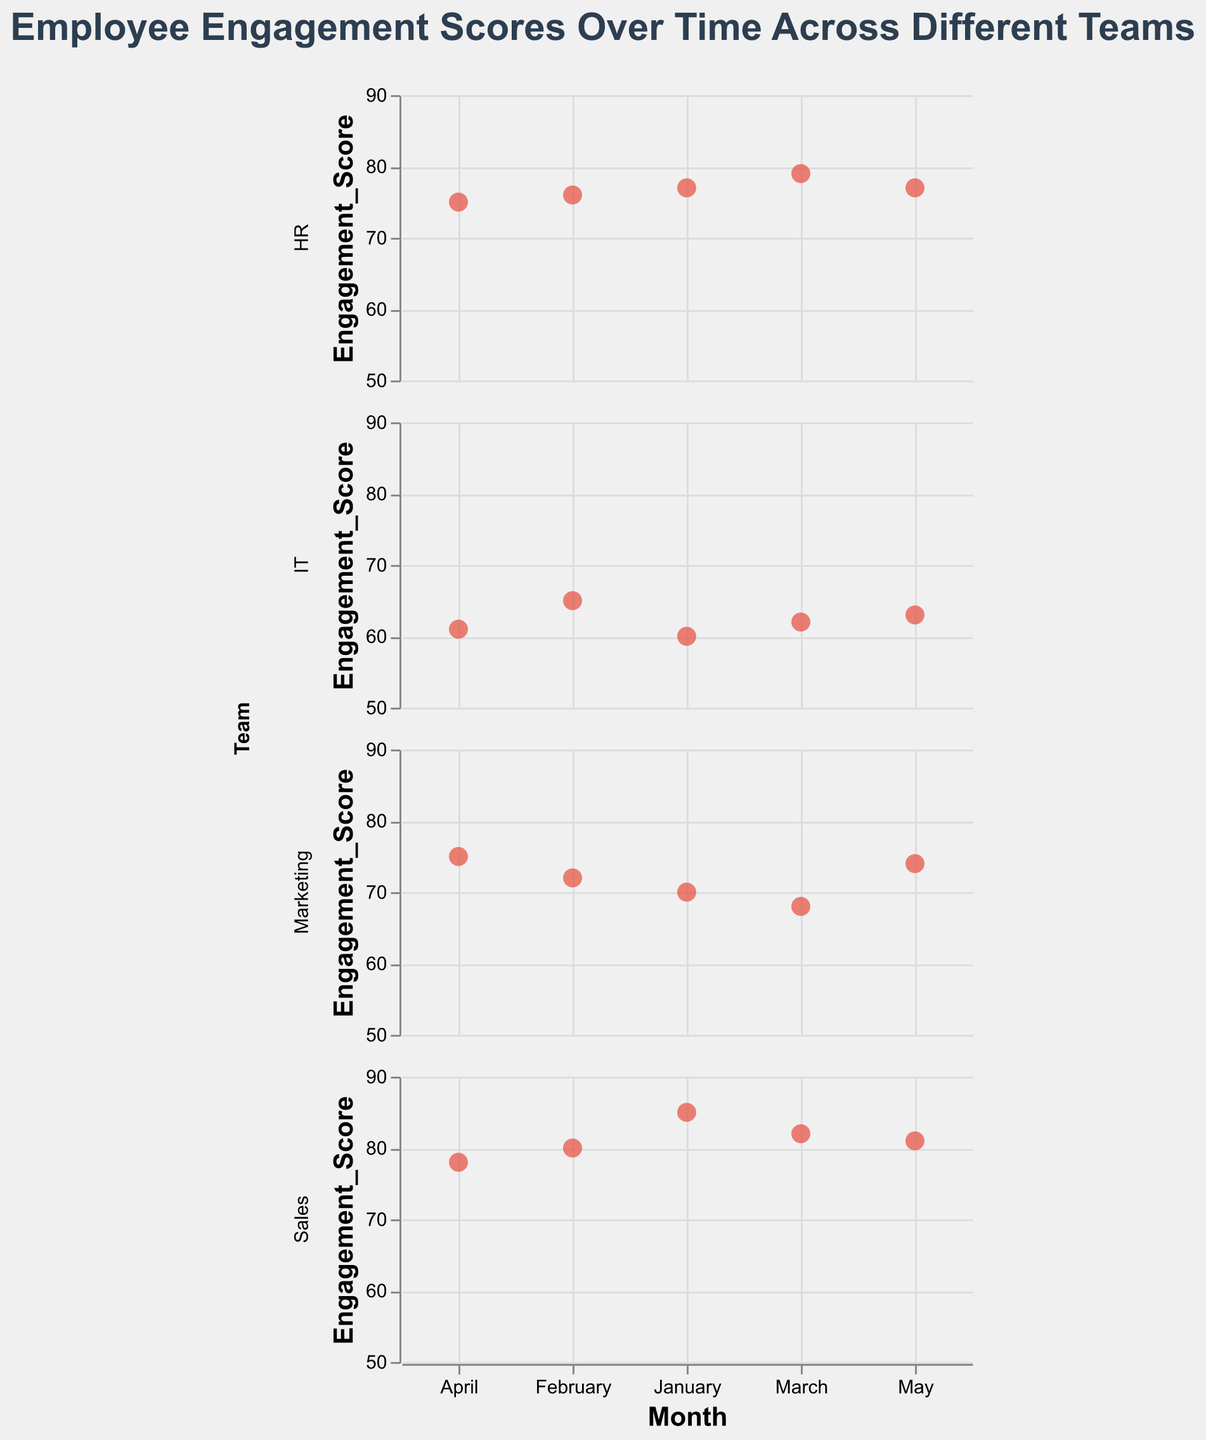What is the title of the figure? The title is usually displayed at the top of the figure and provides a summary of what the figure represents. In this case, it should be "Employee Engagement Scores Over Time Across Different Teams."
Answer: Employee Engagement Scores Over Time Across Different Teams How many teams are displayed in the figure? By looking at the labels or sections on the vertical axis (faceted rows), you can count the number of different teams. Here, the teams are Marketing, Sales, IT, and HR.
Answer: 4 Which team has the highest engagement score in January? By checking the January data points for all teams, we see that the Sales team has the highest engagement score of 85.
Answer: Sales Which team shows the largest increase in engagement score from January to February? We need to calculate the increase for each team: 
- Marketing: 72 - 70 = 2
- Sales: 80 - 85 = -5
- IT: 65 - 60 = 5
- HR: 76 - 77 = -1
The IT team shows the largest increase of 5 points.
Answer: IT Which team had the lowest engagement score in May? By examining the data points for May, we can see:
- Marketing: 74
- Sales: 81
- IT: 63
- HR: 77
The IT team has the lowest engagement score in May with 63 points.
Answer: IT What is the average engagement score for the HR team over the months shown? To calculate the average, sum the scores and divide by the number of months. 
- HR Scores: 77 + 76 + 79 + 75 + 77 = 384
- Number of Months: 5
Average = 384 / 5 = 76.8
Answer: 76.8 Which month shows the most significant drop in engagement score for any team? Check each team for the largest drop between successive months:
- Marketing: March (68) to April (75) (-7)
- Sales: February (80) to March (82) (-2)
- IT: February (65) to March (62) (-3)
- HR: April (75) to May (77) (-2)
The largest drop is for Marketing from February to March with a decrease of 7 points.
Answer: March for Marketing Between Marketing and Sales, which team shows more consistency in their engagement scores? Consistency can be inferred from the variation across months. Calculate the score ranges for both:
- Marketing: Range = 75 - 68 = 7
- Sales: Range = 85 - 78 = 7
Both teams have an equal range and hence similar consistency.
Answer: Neither, both are equally consistent What is the overall trend for the IT team's engagement scores over the 5 months? Observe the pattern of the points for the IT team:
- January: 60
- February: 65
- March: 62
- April: 61
- May: 63
The scores generally fluctuate slightly but show a slight overall increase over time.
Answer: Slight upward trend Which team has the most fluctuating engagement scores over the months? To determine fluctuation, calculate the range (maximum - minimum) for each team:
- Marketing: 75 - 68 = 7
- Sales: 85 - 78 = 7
- IT: 65 - 60 = 5
- HR: 79 - 75 = 4
Both Marketing and Sales have the highest fluctuation range of 7.
Answer: Marketing and Sales 